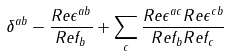<formula> <loc_0><loc_0><loc_500><loc_500>\delta ^ { a b } - { \frac { R e \epsilon ^ { a b } } { R e f _ { b } } } + \sum _ { c } { \frac { R e \epsilon ^ { a c } R e \epsilon ^ { c b } } { R e f _ { b } R e f _ { c } } }</formula> 